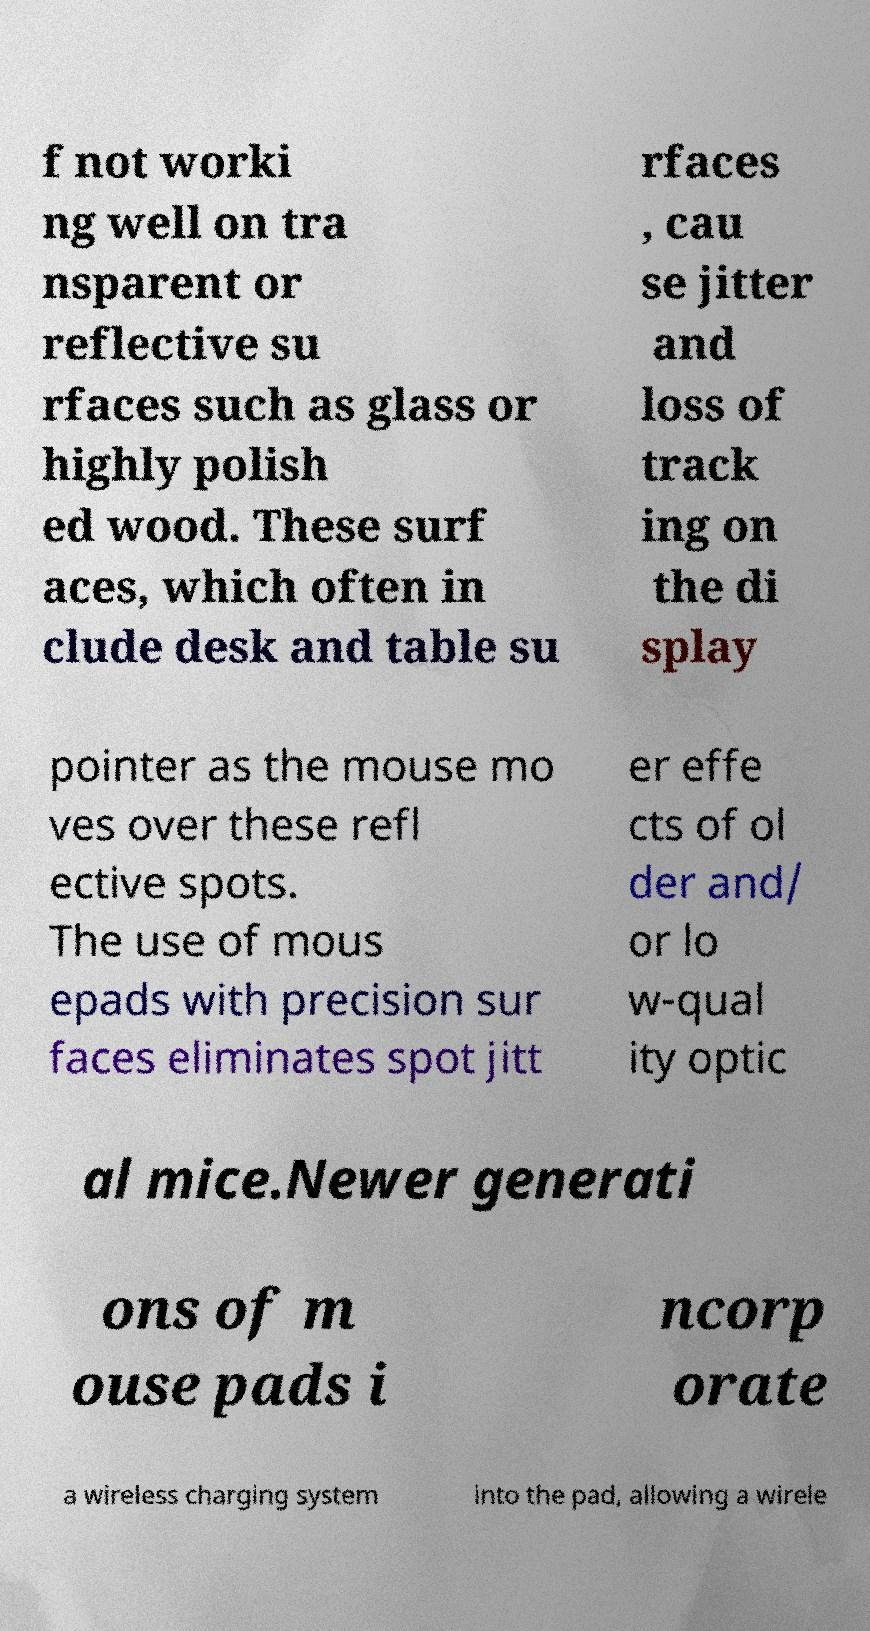Could you assist in decoding the text presented in this image and type it out clearly? f not worki ng well on tra nsparent or reflective su rfaces such as glass or highly polish ed wood. These surf aces, which often in clude desk and table su rfaces , cau se jitter and loss of track ing on the di splay pointer as the mouse mo ves over these refl ective spots. The use of mous epads with precision sur faces eliminates spot jitt er effe cts of ol der and/ or lo w-qual ity optic al mice.Newer generati ons of m ouse pads i ncorp orate a wireless charging system into the pad, allowing a wirele 